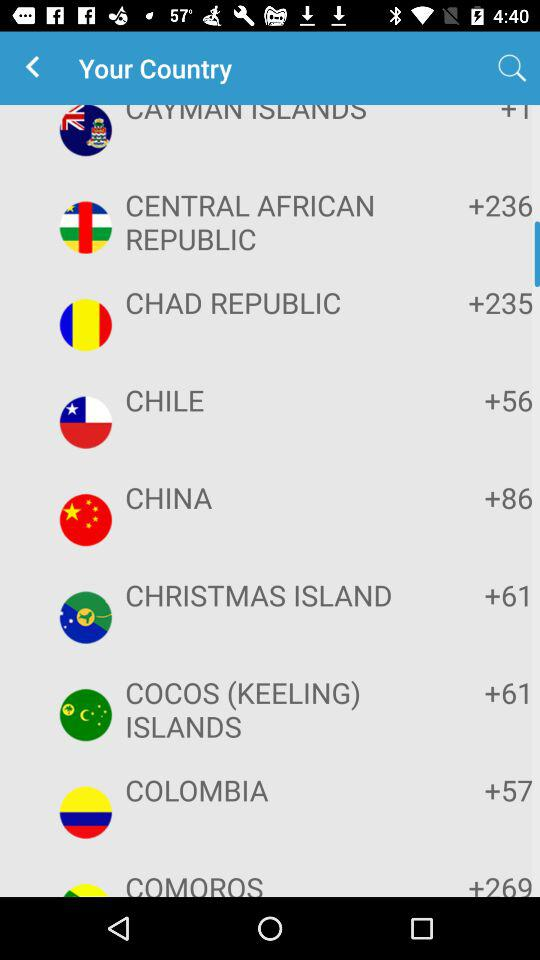What is the code of the Cayman Islands?
When the provided information is insufficient, respond with <no answer>. <no answer> 